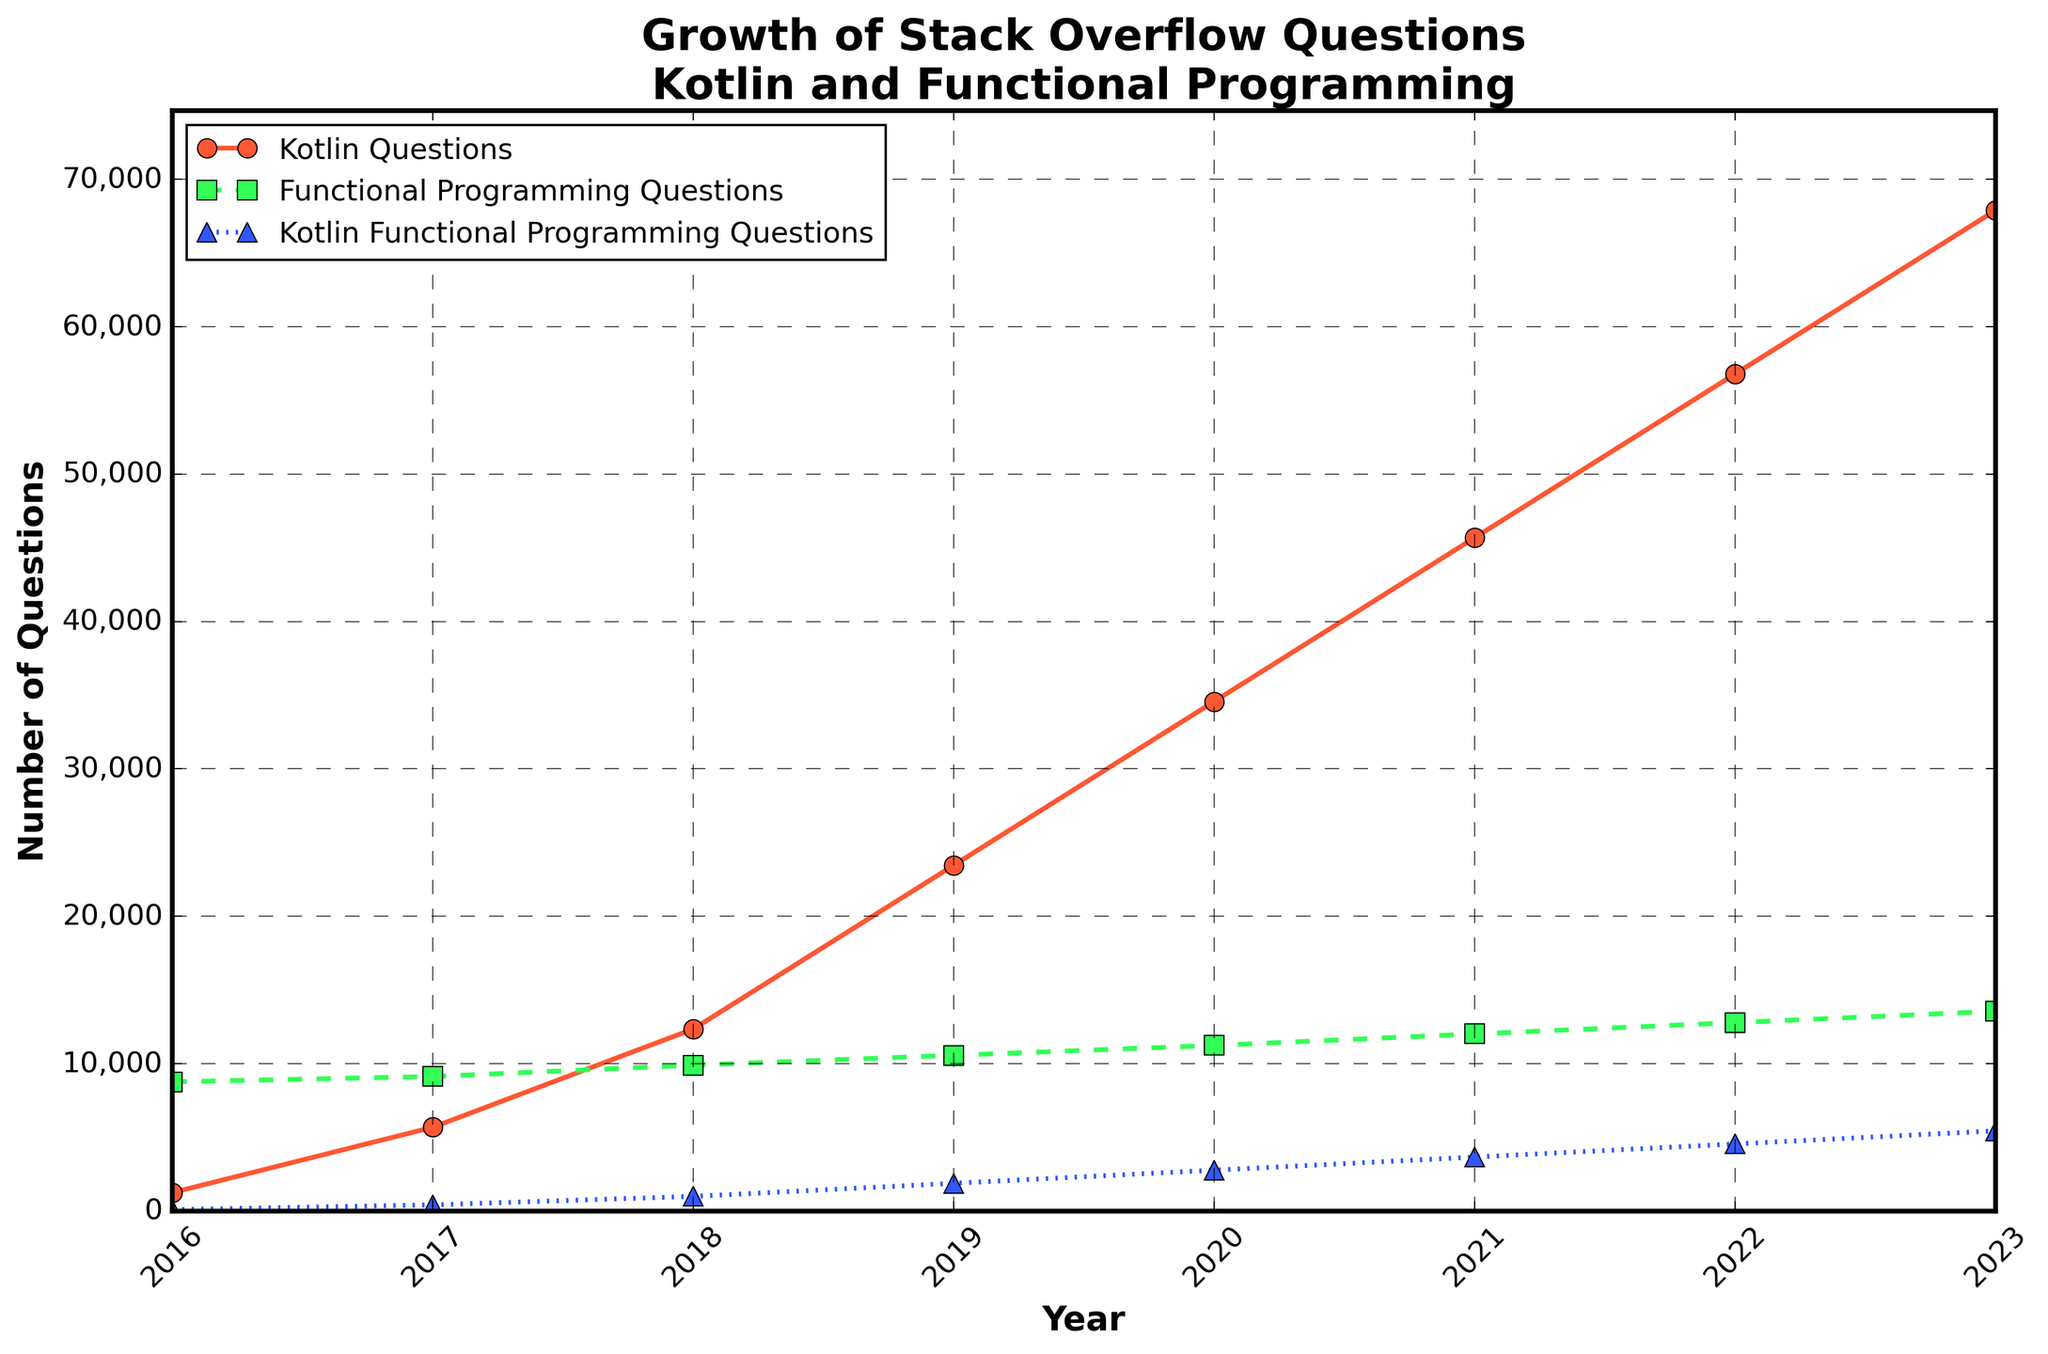What trend is visible in the number of Kotlin questions over the years? From 2016 to 2023, the number of Kotlin questions consistently increases each year. By observing the graph, we see a continuous upward trend without any drop or plateau in the number of questions.
Answer: Increasing Which year experienced the largest increase in Kotlin questions compared to the previous years? To find the largest increase, we compare the difference in the number of Kotlin questions between consecutive years. The largest increase occurs between 2022 (56,789) and 2023 (67,890), which is an increase of 11,101.
Answer: 2023 How do the number of functional programming questions in 2018 and Kotlin functional programming questions in 2023 compare? In 2018, the number of functional programming questions is 9,890, while in 2023, the number of Kotlin functional programming questions is 5,432. Comparing these figures, 9,890 (in 2018) is greater than 5,432 (in 2023).
Answer: Functional Programming Questions in 2018 are higher What is the total number of questions related to Kotlin and functional programming in 2021? To find this, we sum the number of Kotlin questions (45,678) and functional programming questions (12,010) in 2021. The total is 45,678 + 12,010 = 57,688.
Answer: 57,688 Across all years shown, for which pair of years are the differences in the number of Kotlin questions the smallest? We need to calculate the differences between the number of Kotlin questions for each consecutive year and identify the smallest difference: \[ \text{Difference between 2016 and 2017} = 5678 - 1245 = 4433 \] \[ \text{Difference between 2017 and 2018} = 12345 - 5678 = 6667 \] \[ \text{Difference between 2018 and 2019} = 23456 - 12345 = 11111 \] \[ \text{Difference between 2019 and 2020} = 34567 - 23456 = 11111 \] \[ \text{Difference between 2020 and 2021} = 45678 - 34567 = 11111 \] \[ \text{Difference between 2021 and 2022} = 56789 - 45678 = 11111 \] \[ \text{Difference between 2022 and 2023} = 67890 - 56789 = 11101 \] The smallest difference is between 2016 and 2017, which is 4433.
Answer: 2016 and 2017 Which category shows the most gradual growth over the years, and how can you determine this from the graph? By observing the slope and the patterns of the lines, the "Functional Programming Questions" line (green color, dashed line) shows the most gradual growth. Its increase is steady and less steep compared to Kotlin Questions and Kotlin Functional Programming Questions.
Answer: Functional Programming Questions What percentage increase in Kotlin functional programming questions was observed from 2017 to 2018? To find the percentage increase: \(\left(\frac{\text{Kotlin Functional Programming Questions in 2018} - \text{Kotlin Functional Programming Questions in 2017}}{\text{Kotlin Functional Programming Questions in 2017}}\right) \times 100 = \left(\frac{987 - 412}{412}\right) \times 100 = 139.32\%\)
Answer: 139.32% By 2023, what proportion of Kotlin questions are related to functional programming? To find the proportion: \(\frac{\text{Kotlin Functional Programming Questions in 2023}}{\text{Kotlin Questions in 2023}} = \frac{5432}{67890} \approx 0.08\) or about 8%.
Answer: 8% In which year did the number of Kotlin functional programming questions first exceed 1,000? By checking the data, the number of Kotlin functional programming questions first exceeds 1,000 in 2018 where the count is 987+1,000=1,876.
Answer: 2019 By how much did the number of Kotlin questions exceed the number of functional programming questions in 2020? Subtract the number of functional programming questions (11,230) from the number of Kotlin questions (34,567) in 2020: \(34,567 - 11,230 = 23,337\)
Answer: 23,337 